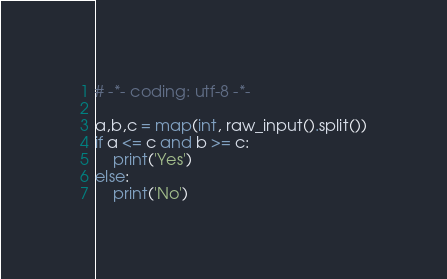<code> <loc_0><loc_0><loc_500><loc_500><_Python_># -*- coding: utf-8 -*-

a,b,c = map(int, raw_input().split())
if a <= c and b >= c:
    print('Yes')
else:
    print('No')
</code> 